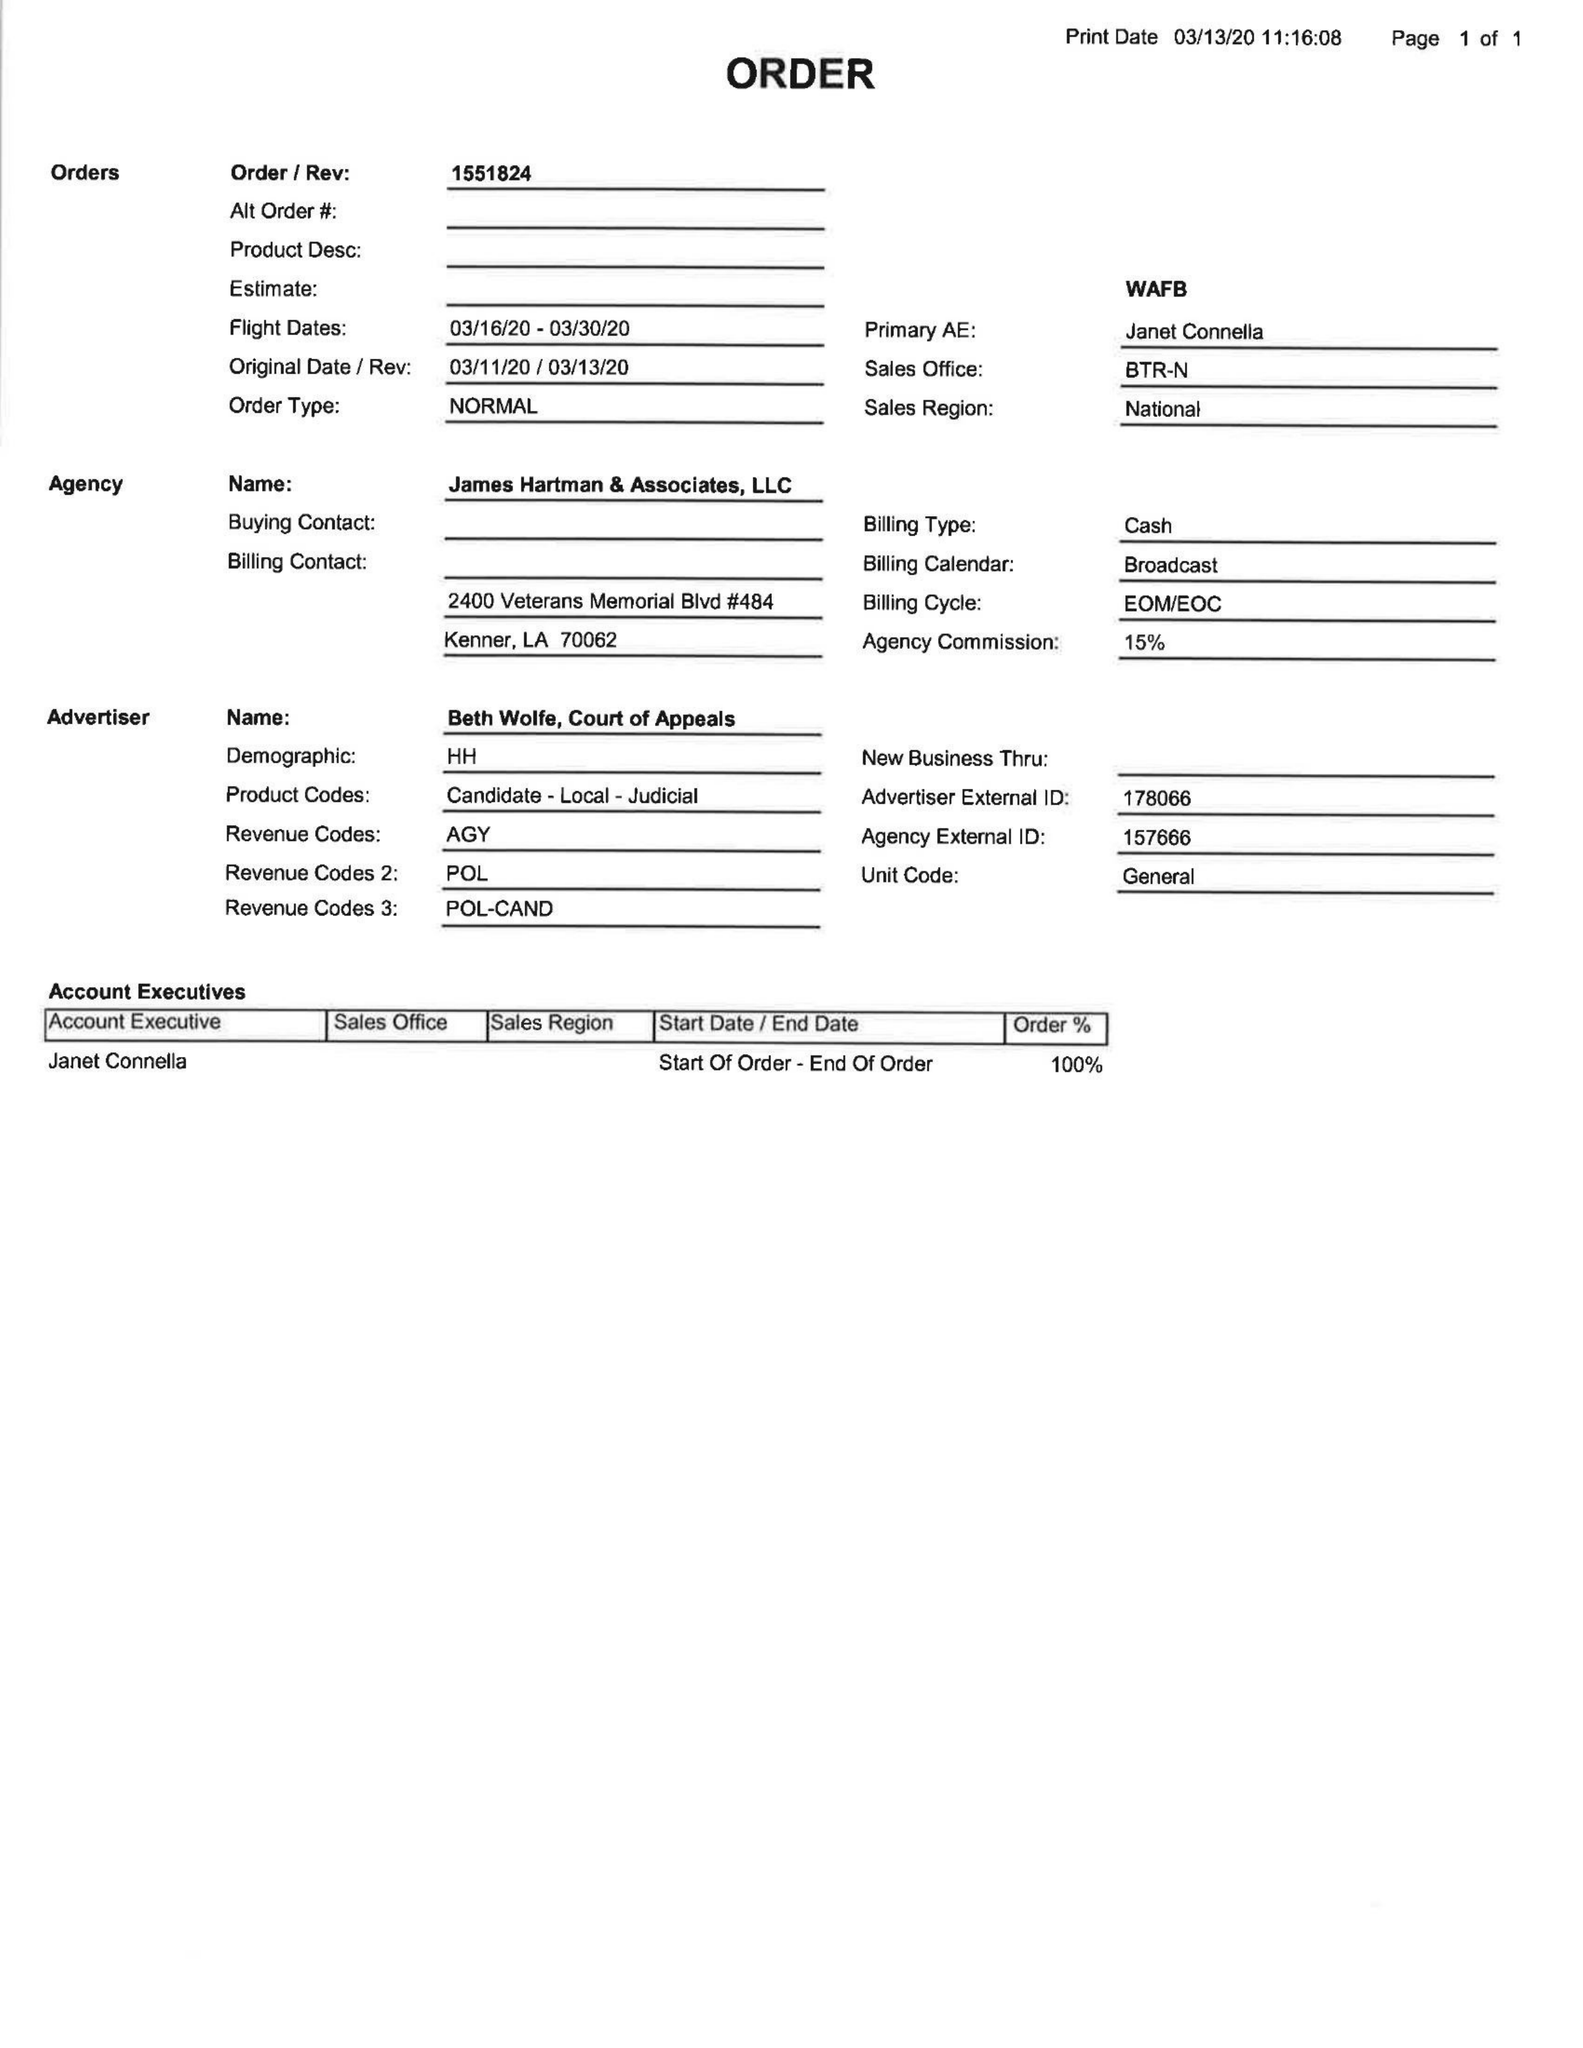What is the value for the gross_amount?
Answer the question using a single word or phrase. None 